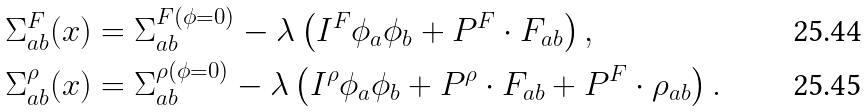Convert formula to latex. <formula><loc_0><loc_0><loc_500><loc_500>\Sigma ^ { F } _ { a b } ( x ) & = \Sigma ^ { F ( \phi = 0 ) } _ { a b } - \lambda \left ( I ^ { F } \phi _ { a } \phi _ { b } + P ^ { F } \cdot F _ { a b } \right ) , \\ \Sigma ^ { \rho } _ { a b } ( x ) & = \Sigma ^ { \rho ( \phi = 0 ) } _ { a b } - \lambda \left ( I ^ { \rho } \phi _ { a } \phi _ { b } + P ^ { \rho } \cdot F _ { a b } + P ^ { F } \cdot \rho _ { a b } \right ) .</formula> 